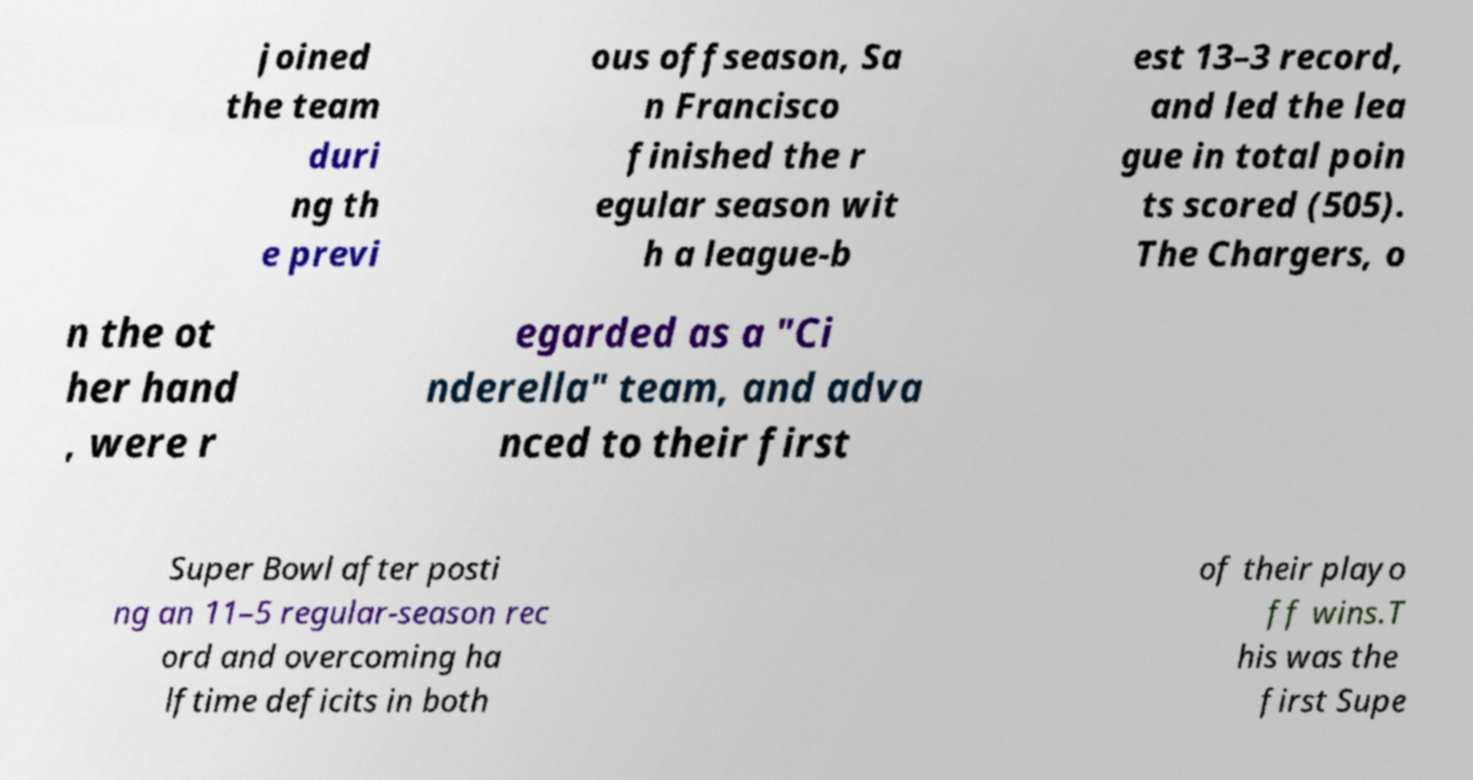Please identify and transcribe the text found in this image. joined the team duri ng th e previ ous offseason, Sa n Francisco finished the r egular season wit h a league-b est 13–3 record, and led the lea gue in total poin ts scored (505). The Chargers, o n the ot her hand , were r egarded as a "Ci nderella" team, and adva nced to their first Super Bowl after posti ng an 11–5 regular-season rec ord and overcoming ha lftime deficits in both of their playo ff wins.T his was the first Supe 